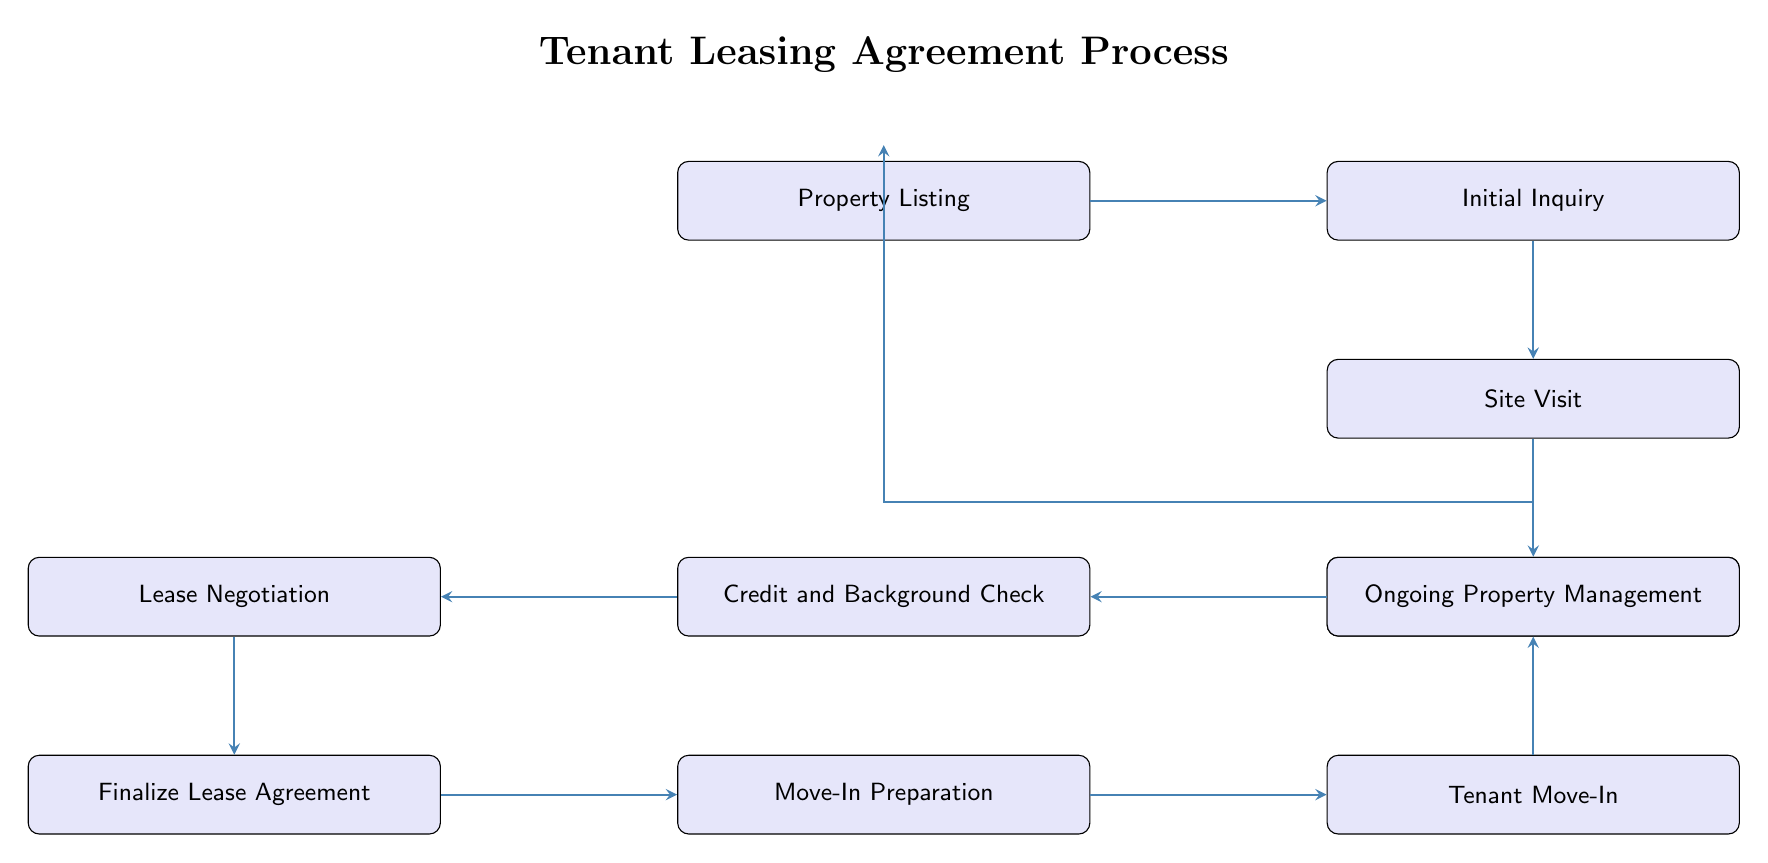What is the first step in the tenant leasing agreement process? The first node in the flow chart is "Property Listing," indicating that this is the initial step of the process where the available commercial properties are published.
Answer: Property Listing How many nodes are there in the flow chart? Counting all distinct steps from "Property Listing" to "Ongoing Property Management," there are 10 nodes in total in the diagram.
Answer: 10 Which step follows the "Application Submission"? The flow chart shows that the node directly below "Application Submission" is "Credit and Background Check," indicating this is the subsequent step.
Answer: Credit and Background Check What is the last step in the process? The final node at the bottom of the flow chart is "Ongoing Property Management," showing this is the last phase after tenant move-in.
Answer: Ongoing Property Management What action is associated with the "Tenant Move-In" node? The diagram shows that the process includes a "move-in inspection" during the "Tenant Move-In" phase, which is critical for confirming property condition upon tenant arrival.
Answer: Move-in inspection What two steps directly precede "Finalize Lease Agreement"? The flow chart indicates that "Lease Negotiation" occurs right before "Finalize Lease Agreement," and it is preceded by "Credit and Background Check," illustrating their sequential relationship.
Answer: Lease Negotiation, Credit and Background Check How does "Site Visit" relate to "Initial Inquiry"? The flow chart connects "Initial Inquiry" to "Site Visit" by an arrow, indicating that site visits are scheduled following initial inquiries by potential tenants about property details.
Answer: After Which node is linked to "Move-In Preparation"? The diagram indicates that "Move-In Preparation" is directly before "Tenant Move-In," implying that preparations are made for the tenant's arrival at this stage.
Answer: Tenant Move-In How do you return to the start of the process from "Ongoing Property Management"? The diagram illustrates a connection from "Ongoing Property Management" back to "Property Listing," indicating there is a cyclical aspect where property management informs the cycle of re-listing properties if necessary.
Answer: Back to Property Listing 